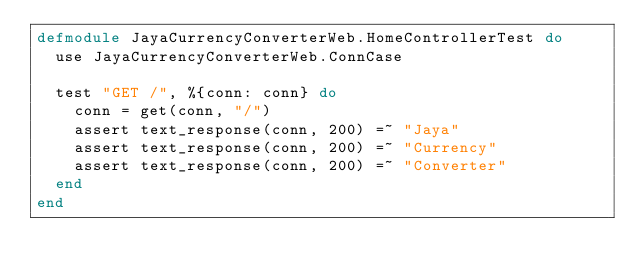Convert code to text. <code><loc_0><loc_0><loc_500><loc_500><_Elixir_>defmodule JayaCurrencyConverterWeb.HomeControllerTest do
  use JayaCurrencyConverterWeb.ConnCase

  test "GET /", %{conn: conn} do
    conn = get(conn, "/")
    assert text_response(conn, 200) =~ "Jaya"
    assert text_response(conn, 200) =~ "Currency"
    assert text_response(conn, 200) =~ "Converter"
  end
end
</code> 